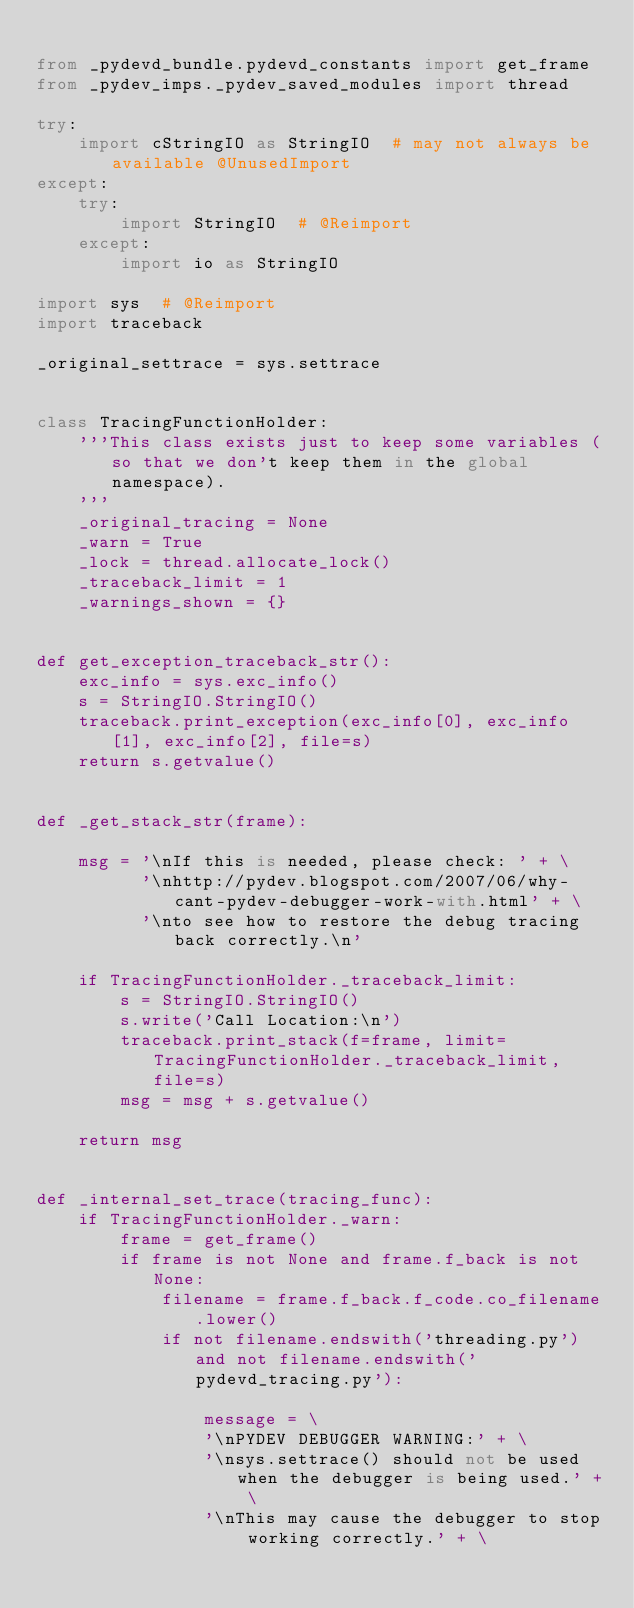<code> <loc_0><loc_0><loc_500><loc_500><_Python_>
from _pydevd_bundle.pydevd_constants import get_frame
from _pydev_imps._pydev_saved_modules import thread

try:
    import cStringIO as StringIO  # may not always be available @UnusedImport
except:
    try:
        import StringIO  # @Reimport
    except:
        import io as StringIO

import sys  # @Reimport
import traceback

_original_settrace = sys.settrace


class TracingFunctionHolder:
    '''This class exists just to keep some variables (so that we don't keep them in the global namespace).
    '''
    _original_tracing = None
    _warn = True
    _lock = thread.allocate_lock()
    _traceback_limit = 1
    _warnings_shown = {}


def get_exception_traceback_str():
    exc_info = sys.exc_info()
    s = StringIO.StringIO()
    traceback.print_exception(exc_info[0], exc_info[1], exc_info[2], file=s)
    return s.getvalue()


def _get_stack_str(frame):

    msg = '\nIf this is needed, please check: ' + \
          '\nhttp://pydev.blogspot.com/2007/06/why-cant-pydev-debugger-work-with.html' + \
          '\nto see how to restore the debug tracing back correctly.\n'

    if TracingFunctionHolder._traceback_limit:
        s = StringIO.StringIO()
        s.write('Call Location:\n')
        traceback.print_stack(f=frame, limit=TracingFunctionHolder._traceback_limit, file=s)
        msg = msg + s.getvalue()

    return msg


def _internal_set_trace(tracing_func):
    if TracingFunctionHolder._warn:
        frame = get_frame()
        if frame is not None and frame.f_back is not None:
            filename = frame.f_back.f_code.co_filename.lower()
            if not filename.endswith('threading.py') and not filename.endswith('pydevd_tracing.py'):

                message = \
                '\nPYDEV DEBUGGER WARNING:' + \
                '\nsys.settrace() should not be used when the debugger is being used.' + \
                '\nThis may cause the debugger to stop working correctly.' + \</code> 